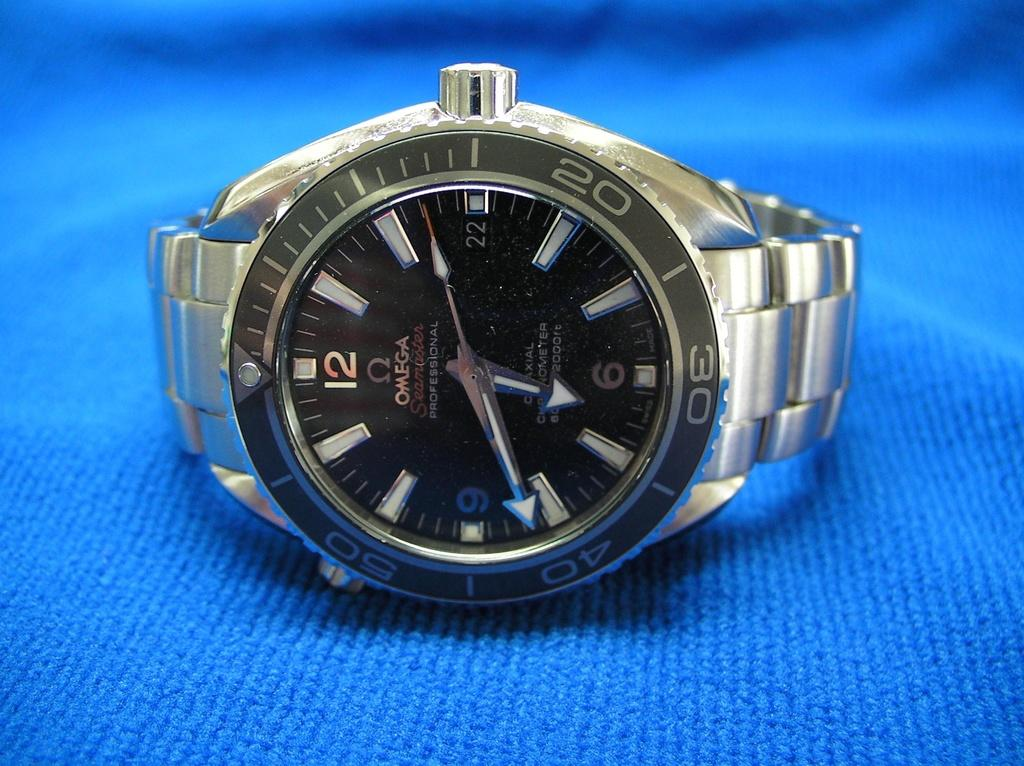Provide a one-sentence caption for the provided image. An omega seamaster professional watch sits on a towel. 